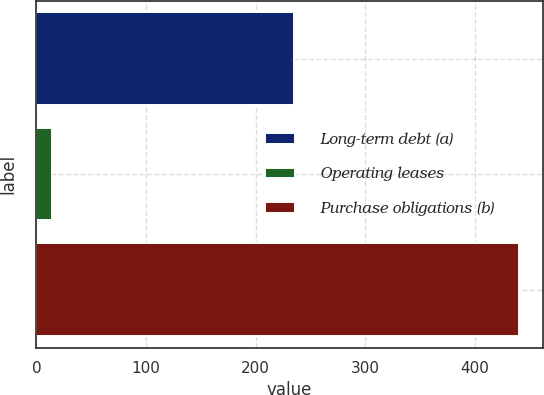Convert chart to OTSL. <chart><loc_0><loc_0><loc_500><loc_500><bar_chart><fcel>Long-term debt (a)<fcel>Operating leases<fcel>Purchase obligations (b)<nl><fcel>235<fcel>14<fcel>440<nl></chart> 